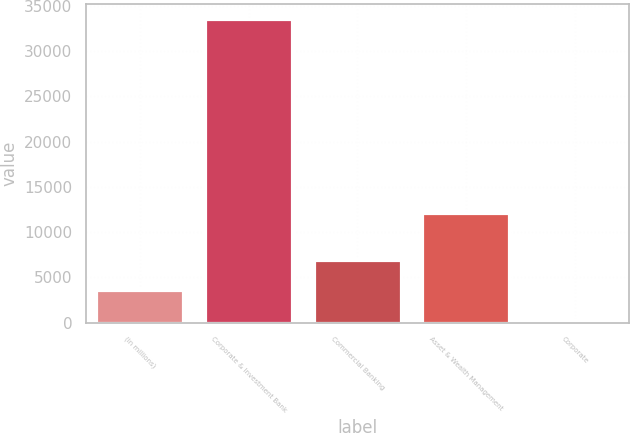Convert chart. <chart><loc_0><loc_0><loc_500><loc_500><bar_chart><fcel>(in millions)<fcel>Corporate & Investment Bank<fcel>Commercial Banking<fcel>Asset & Wealth Management<fcel>Corporate<nl><fcel>3594.5<fcel>33542<fcel>6922<fcel>12119<fcel>267<nl></chart> 